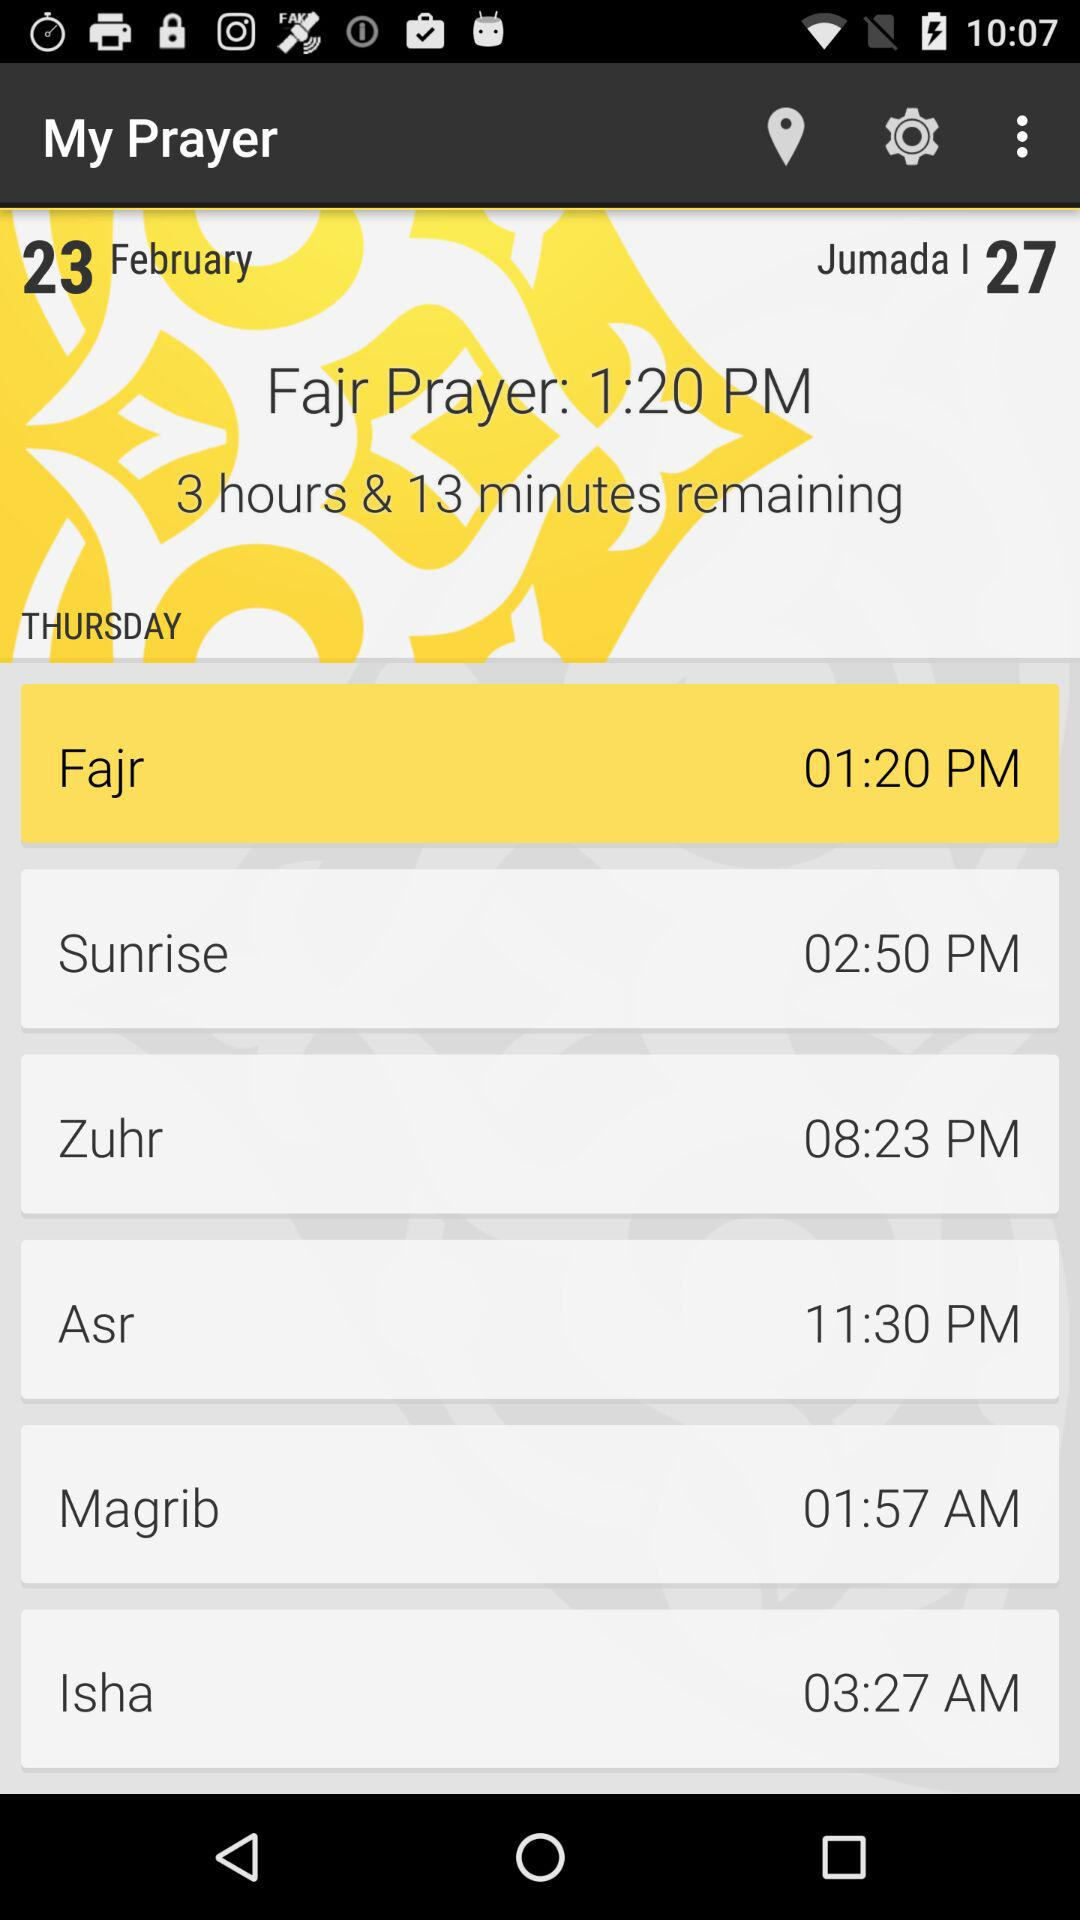Which date is mentioned? The mentioned date is Thursday, February 23. 